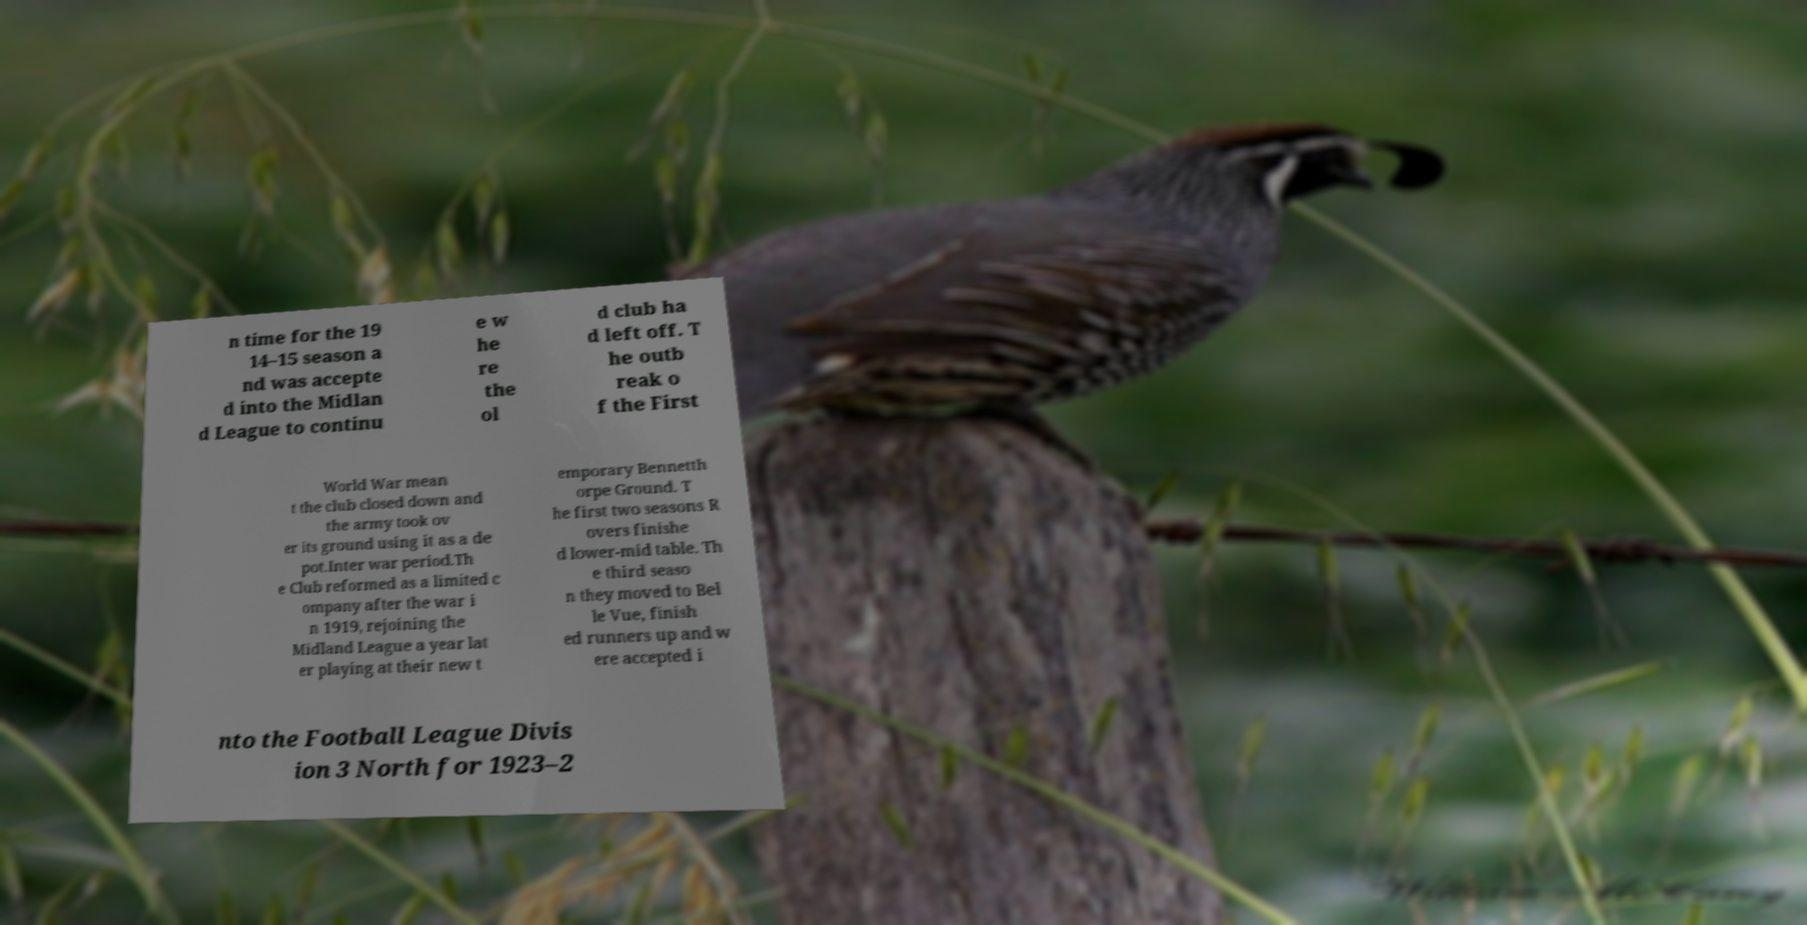Could you extract and type out the text from this image? n time for the 19 14–15 season a nd was accepte d into the Midlan d League to continu e w he re the ol d club ha d left off. T he outb reak o f the First World War mean t the club closed down and the army took ov er its ground using it as a de pot.Inter war period.Th e Club reformed as a limited c ompany after the war i n 1919, rejoining the Midland League a year lat er playing at their new t emporary Bennetth orpe Ground. T he first two seasons R overs finishe d lower-mid table. Th e third seaso n they moved to Bel le Vue, finish ed runners up and w ere accepted i nto the Football League Divis ion 3 North for 1923–2 